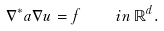Convert formula to latex. <formula><loc_0><loc_0><loc_500><loc_500>\nabla ^ { * } a \nabla u = f \quad i n \, \mathbb { R } ^ { d } .</formula> 